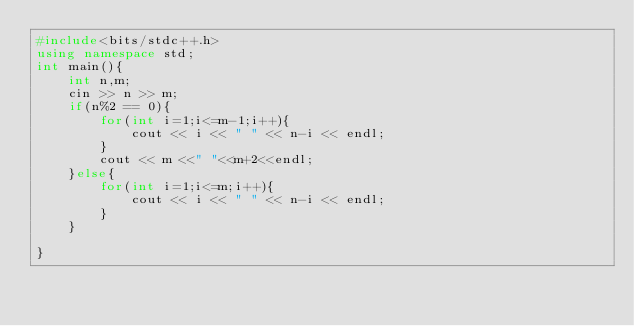Convert code to text. <code><loc_0><loc_0><loc_500><loc_500><_C++_>#include<bits/stdc++.h>
using namespace std;
int main(){
    int n,m;
    cin >> n >> m;
    if(n%2 == 0){
        for(int i=1;i<=m-1;i++){
            cout << i << " " << n-i << endl;
        }
        cout << m <<" "<<m+2<<endl;
    }else{
        for(int i=1;i<=m;i++){
            cout << i << " " << n-i << endl;
        }
    }

}</code> 